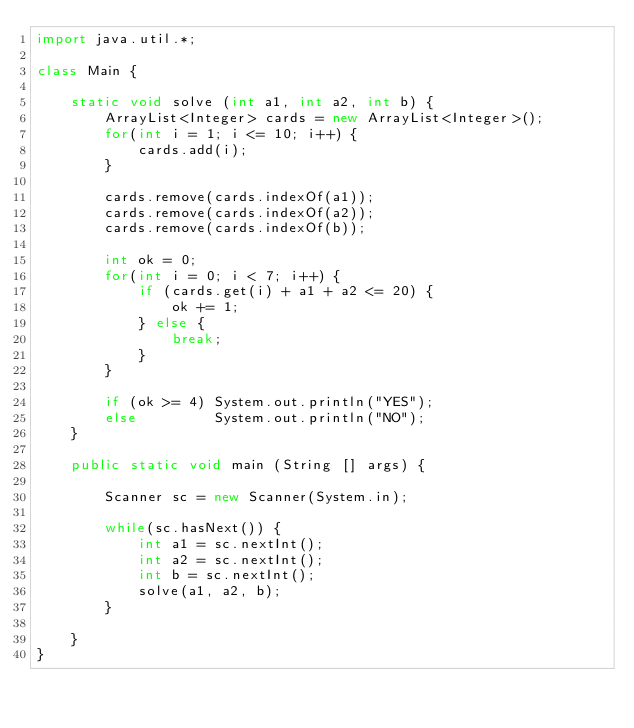<code> <loc_0><loc_0><loc_500><loc_500><_Java_>import java.util.*;

class Main {

    static void solve (int a1, int a2, int b) {
        ArrayList<Integer> cards = new ArrayList<Integer>();
        for(int i = 1; i <= 10; i++) {
            cards.add(i);
        }

        cards.remove(cards.indexOf(a1));
        cards.remove(cards.indexOf(a2));
        cards.remove(cards.indexOf(b));

        int ok = 0;
        for(int i = 0; i < 7; i++) {
            if (cards.get(i) + a1 + a2 <= 20) {
                ok += 1;
            } else {
                break;
            }
        }

        if (ok >= 4) System.out.println("YES");
        else         System.out.println("NO");
    }

    public static void main (String [] args) {

        Scanner sc = new Scanner(System.in);

        while(sc.hasNext()) {
            int a1 = sc.nextInt();
            int a2 = sc.nextInt();
            int b = sc.nextInt();
            solve(a1, a2, b);
        }

    }
}</code> 